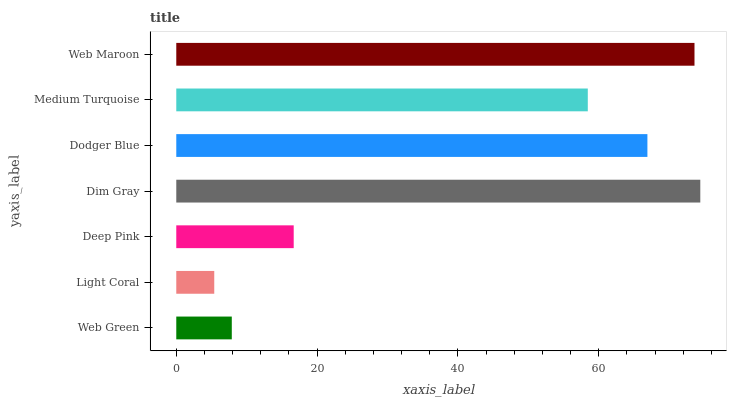Is Light Coral the minimum?
Answer yes or no. Yes. Is Dim Gray the maximum?
Answer yes or no. Yes. Is Deep Pink the minimum?
Answer yes or no. No. Is Deep Pink the maximum?
Answer yes or no. No. Is Deep Pink greater than Light Coral?
Answer yes or no. Yes. Is Light Coral less than Deep Pink?
Answer yes or no. Yes. Is Light Coral greater than Deep Pink?
Answer yes or no. No. Is Deep Pink less than Light Coral?
Answer yes or no. No. Is Medium Turquoise the high median?
Answer yes or no. Yes. Is Medium Turquoise the low median?
Answer yes or no. Yes. Is Deep Pink the high median?
Answer yes or no. No. Is Light Coral the low median?
Answer yes or no. No. 